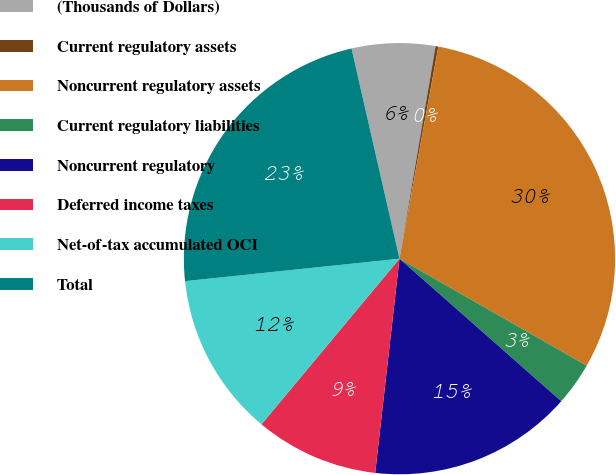Convert chart to OTSL. <chart><loc_0><loc_0><loc_500><loc_500><pie_chart><fcel>(Thousands of Dollars)<fcel>Current regulatory assets<fcel>Noncurrent regulatory assets<fcel>Current regulatory liabilities<fcel>Noncurrent regulatory<fcel>Deferred income taxes<fcel>Net-of-tax accumulated OCI<fcel>Total<nl><fcel>6.25%<fcel>0.21%<fcel>30.38%<fcel>3.23%<fcel>15.3%<fcel>9.26%<fcel>12.28%<fcel>23.09%<nl></chart> 